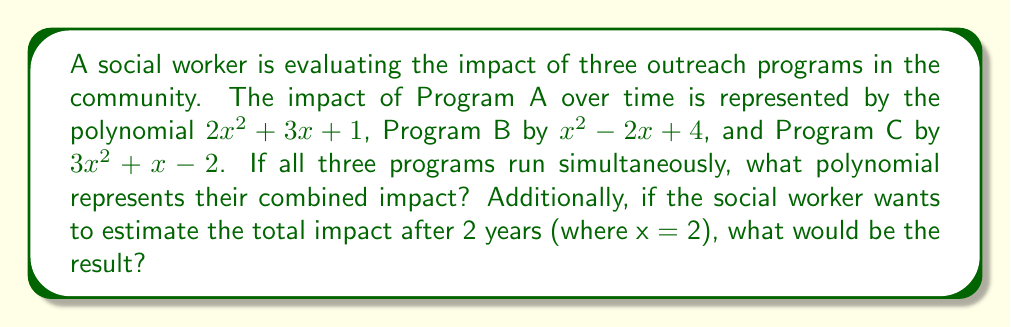Solve this math problem. 1. To find the combined impact of all three programs, we need to add the polynomials:

   Program A: $2x^2 + 3x + 1$
   Program B: $x^2 - 2x + 4$
   Program C: $3x^2 + x - 2$

   $$(2x^2 + 3x + 1) + (x^2 - 2x + 4) + (3x^2 + x - 2)$$

2. Combining like terms:
   
   $$6x^2 + 2x + 3$$

3. This polynomial represents the combined impact of all three programs.

4. To estimate the total impact after 2 years, we substitute x = 2 into the combined polynomial:

   $$6(2)^2 + 2(2) + 3$$

5. Simplify:
   
   $$6(4) + 4 + 3$$
   $$24 + 4 + 3$$
   $$31$$

Therefore, the estimated total impact after 2 years is 31 units.
Answer: Combined impact: $6x^2 + 2x + 3$; Total impact after 2 years: 31 